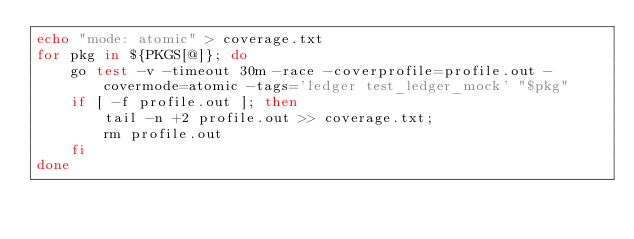Convert code to text. <code><loc_0><loc_0><loc_500><loc_500><_Bash_>echo "mode: atomic" > coverage.txt
for pkg in ${PKGS[@]}; do
    go test -v -timeout 30m -race -coverprofile=profile.out -covermode=atomic -tags='ledger test_ledger_mock' "$pkg"
    if [ -f profile.out ]; then
        tail -n +2 profile.out >> coverage.txt;
        rm profile.out
    fi
done
</code> 